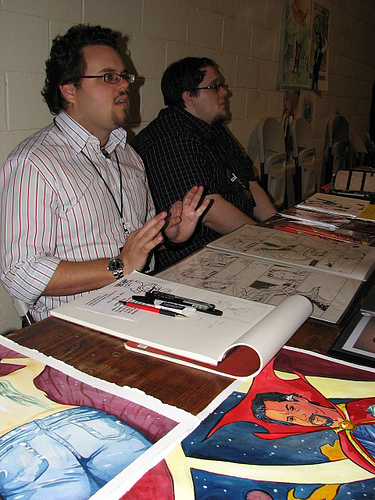<image>
Can you confirm if the poster is under the sketchbook? No. The poster is not positioned under the sketchbook. The vertical relationship between these objects is different. 